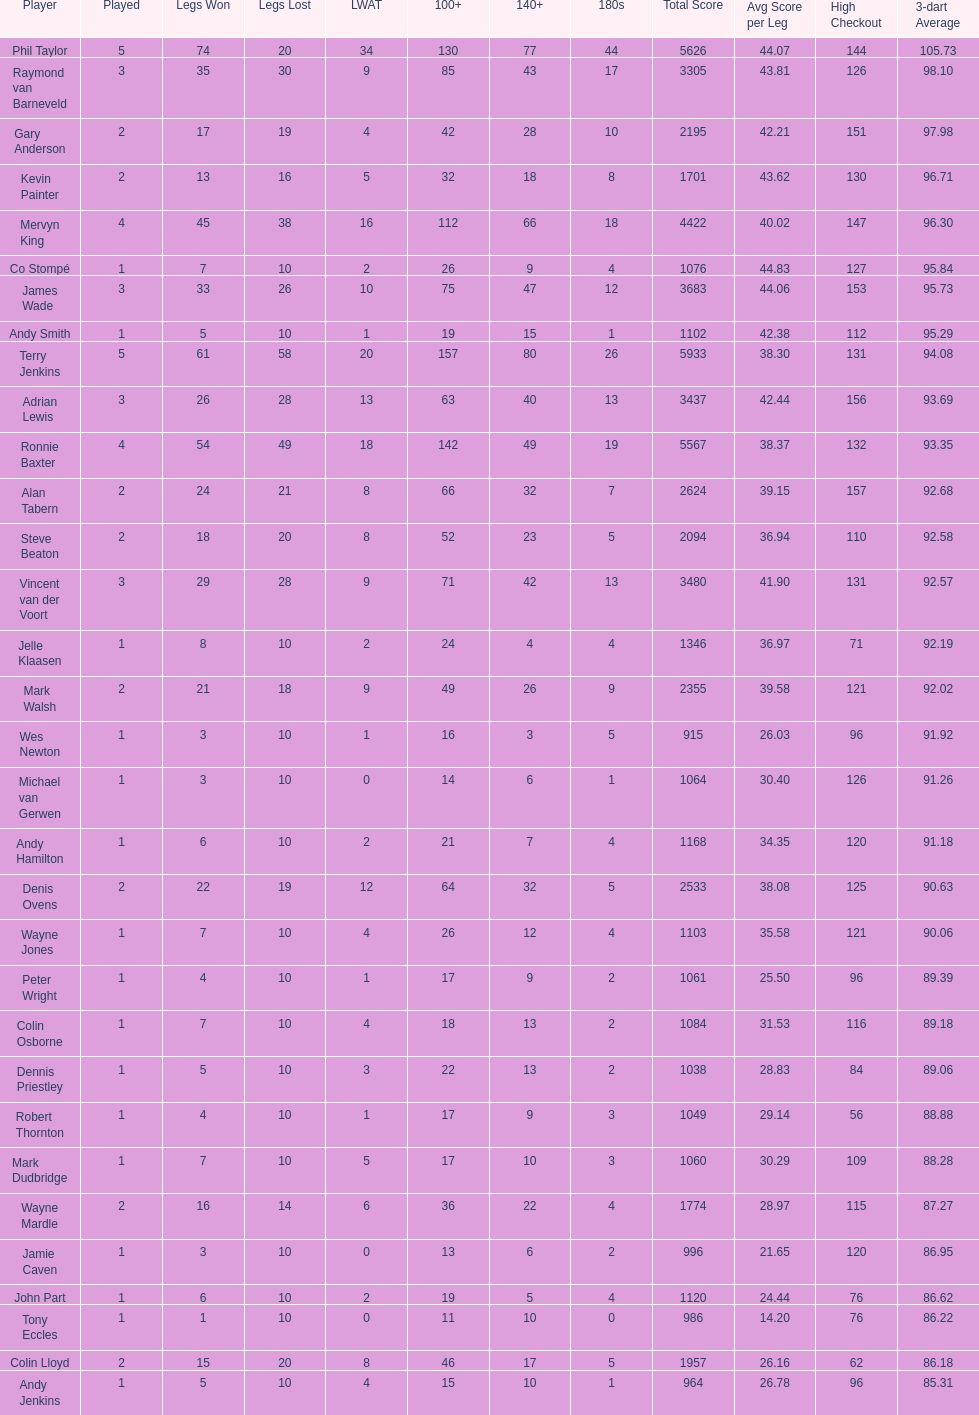Which player has his high checkout as 116? Colin Osborne. 